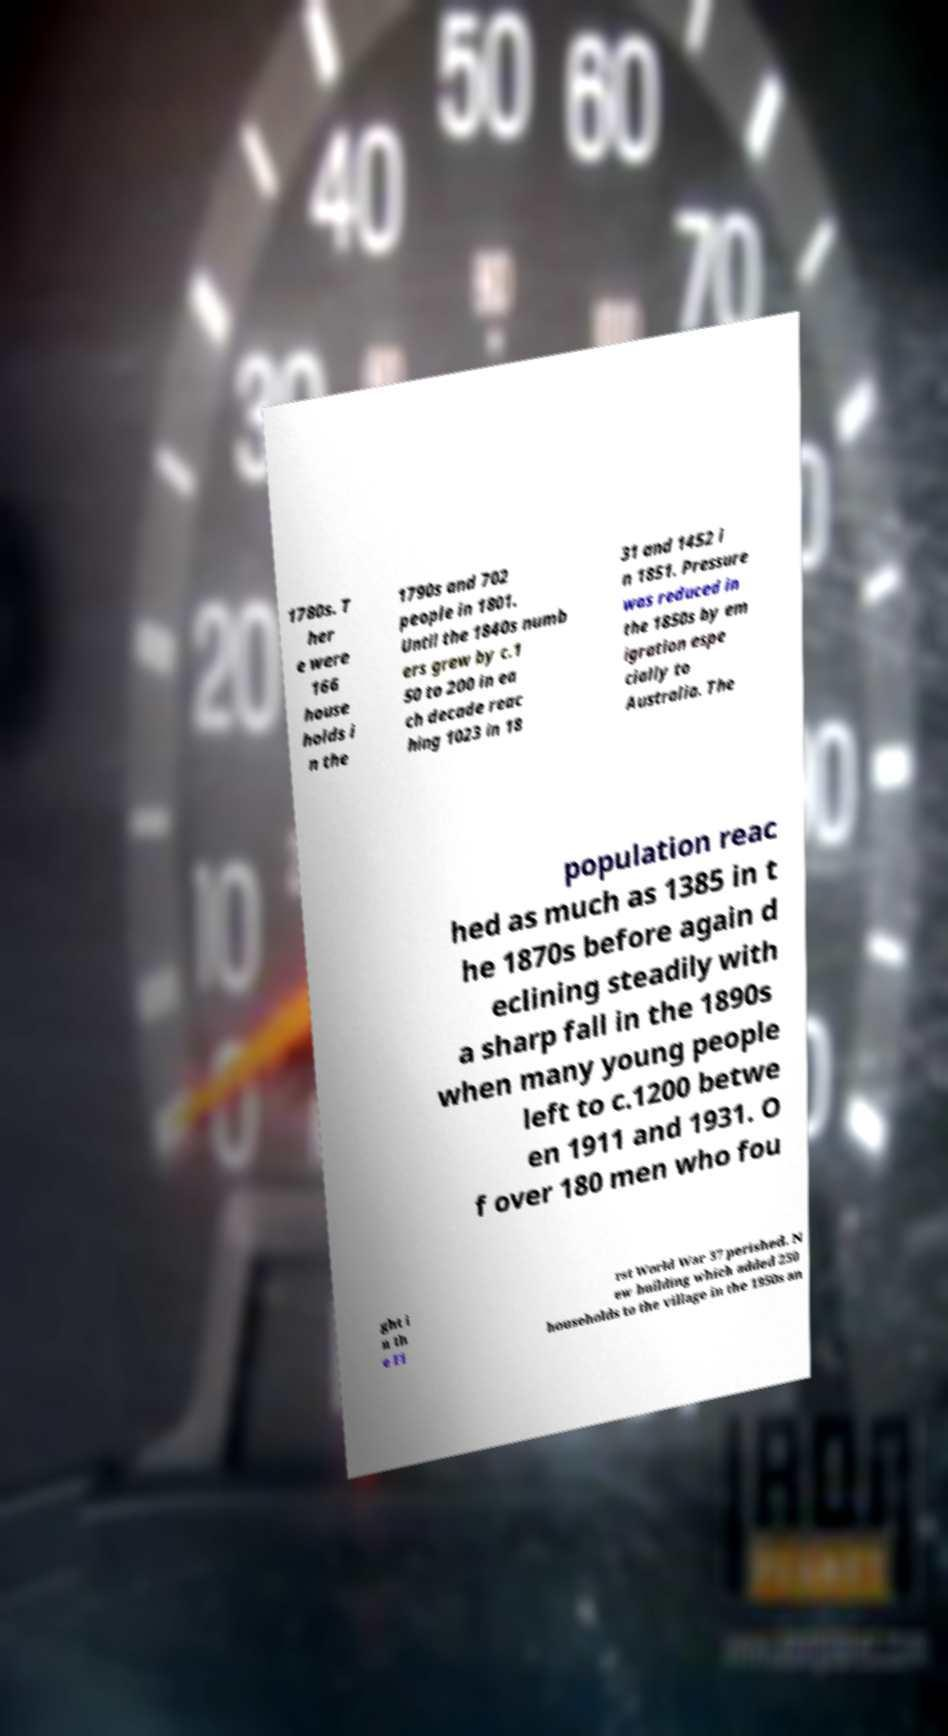There's text embedded in this image that I need extracted. Can you transcribe it verbatim? 1780s. T her e were 166 house holds i n the 1790s and 702 people in 1801. Until the 1840s numb ers grew by c.1 50 to 200 in ea ch decade reac hing 1023 in 18 31 and 1452 i n 1851. Pressure was reduced in the 1850s by em igration espe cially to Australia. The population reac hed as much as 1385 in t he 1870s before again d eclining steadily with a sharp fall in the 1890s when many young people left to c.1200 betwe en 1911 and 1931. O f over 180 men who fou ght i n th e Fi rst World War 37 perished. N ew building which added 250 households to the village in the 1950s an 